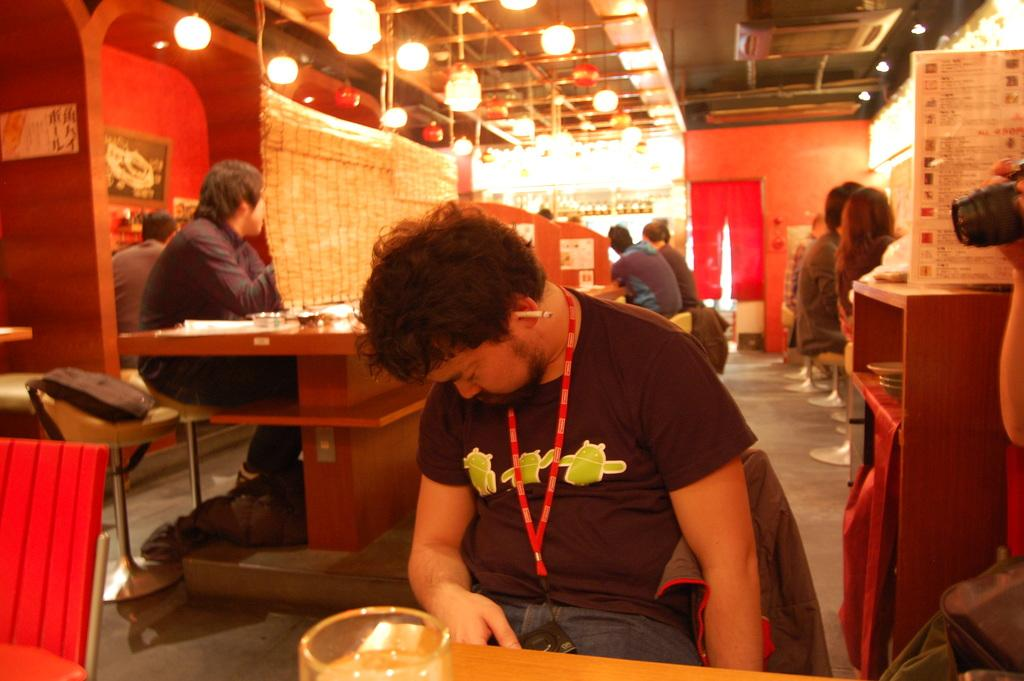What is the person in the image doing? The person is sitting on a chair in the image. What is in front of the person? There is a table in front of the person. Are there any other people in the image? Yes, there is a group of people sitting at the back of the person. What can be seen at the top of the image? There are lights visible at the top of the image. How does the person in the image control the thrill of the observation? There is no mention of control, thrill, or observation in the image, so it is not possible to answer this question based on the provided facts. 